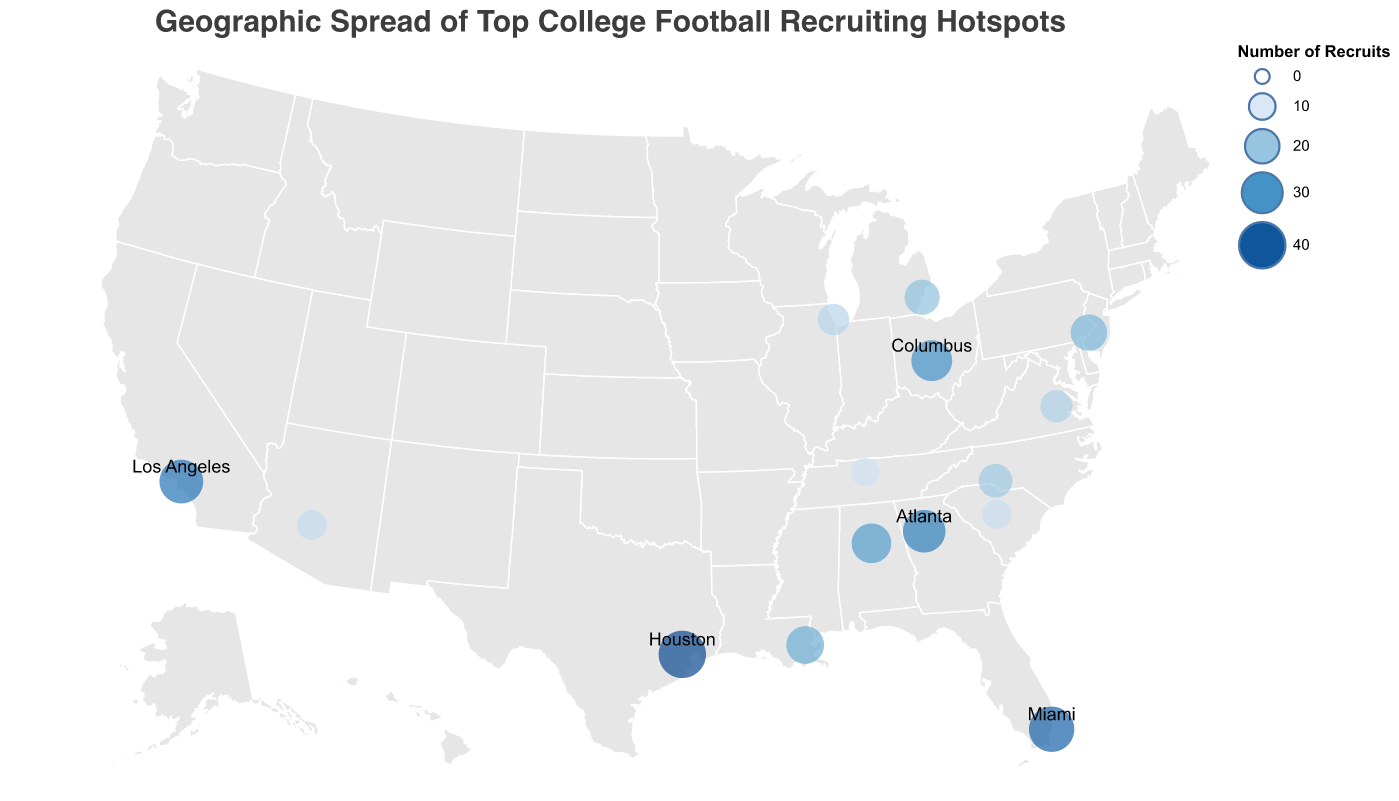What's the title of the figure? The title is displayed at the top of the figure in a large font. It reads, "Geographic Spread of Top College Football Recruiting Hotspots."
Answer: Geographic Spread of Top College Football Recruiting Hotspots How many cities are represented on the map? Each circle on the map represents a city, and there are circles of various sizes and colors scattered across the U.S. By counting them, you can identify the number of cities.
Answer: 15 Which city has the highest number of recruits? The size and color intensity of the circles indicate the number of recruits, with larger, darker circles having more recruits. The largest and darkest circle is over Houston.
Answer: Houston What is the combined number of recruits from Los Angeles and Miami? Los Angeles has 35 recruits and Miami has 38 recruits. Adding them together gives the total.
Answer: 73 Which city in the southeastern U.S. other than Miami has a high number of recruits? By looking at the southeastern region of the map, Atlanta stands out with a large and dark circle, indicating a high number of recruits.
Answer: Atlanta How does the number of recruits in Atlanta compare to Columbus? Atlanta's circle represents 33 recruits and Columbus's circle represents 30 recruits. Compare the two values directly to see that Atlanta has more recruits.
Answer: Atlanta has more What is the average number of recruits across Los Angeles, Birmingham, and New Orleans? The numbers of recruits in Los Angeles (35), Birmingham (28), and New Orleans (25) are summed and then divided by the number of cities to find the average: (35 + 28 + 25) / 3 = 88 / 3 = 29.33.
Answer: 29.33 Which state has the most cities listed as recruiting hotspots? By looking at the states for each city and counting the occurrences, Texas stands out with Houston as its city. Most states have only one hotspot listed.
Answer: Texas Are there more recruits in Chicago or Phoenix? Compare the numbers directly from the map. Chicago has 16 recruits and Phoenix has 14 recruits. Chicago has more.
Answer: Chicago has more What geographic pattern can you notice among the cities with the highest numbers of recruits? Examining the map, the cities with the highest numbers of recruits (largest and darkest circles) are primarily situated in the southern and southeastern regions of the U.S.
Answer: Southern and southeastern regions 